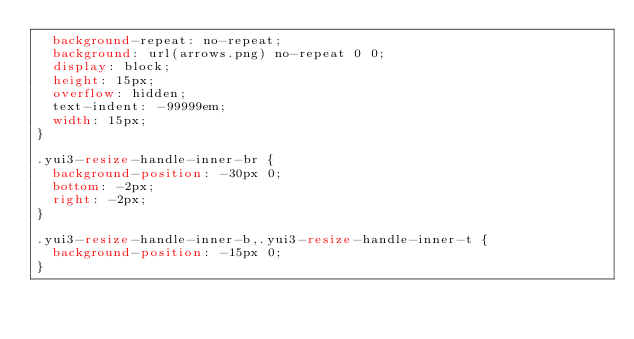Convert code to text. <code><loc_0><loc_0><loc_500><loc_500><_CSS_>	background-repeat: no-repeat;
	background: url(arrows.png) no-repeat 0 0;
	display: block;
	height: 15px;
	overflow: hidden;
	text-indent: -99999em;
	width: 15px;
}

.yui3-resize-handle-inner-br {
	background-position: -30px 0;
	bottom: -2px;
	right: -2px;
}

.yui3-resize-handle-inner-b,.yui3-resize-handle-inner-t {
	background-position: -15px 0;
}</code> 